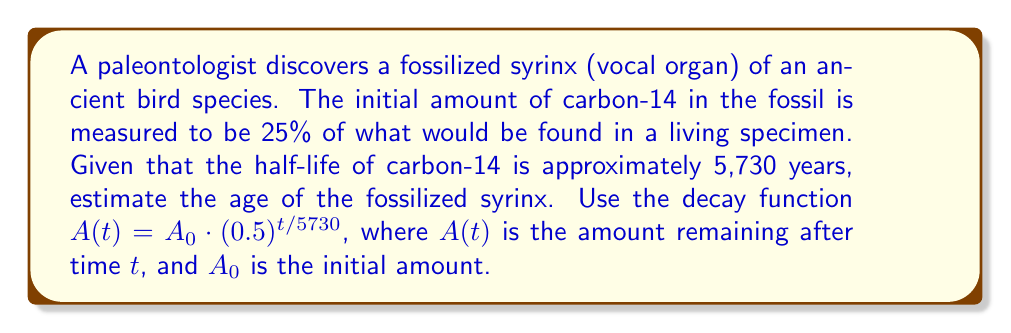Can you solve this math problem? To solve this problem, we'll use the decay function and the given information:

1. Let $A_0 = 100\%$ (initial amount in a living specimen)
2. $A(t) = 25\%$ (current amount in the fossil)
3. Half-life = 5,730 years

We'll substitute these values into the decay function:

$$25 = 100 \cdot (0.5)^{t/5730}$$

Now, we'll solve for $t$:

1. Divide both sides by 100:
   $$0.25 = (0.5)^{t/5730}$$

2. Take the natural log of both sides:
   $$\ln(0.25) = \ln((0.5)^{t/5730})$$

3. Use the logarithm property $\ln(a^b) = b\ln(a)$:
   $$\ln(0.25) = \frac{t}{5730} \cdot \ln(0.5)$$

4. Solve for $t$:
   $$t = \frac{\ln(0.25) \cdot 5730}{\ln(0.5)}$$

5. Calculate the result:
   $$t \approx 11,460 \text{ years}$$

Therefore, the estimated age of the fossilized syrinx is approximately 11,460 years.
Answer: 11,460 years 